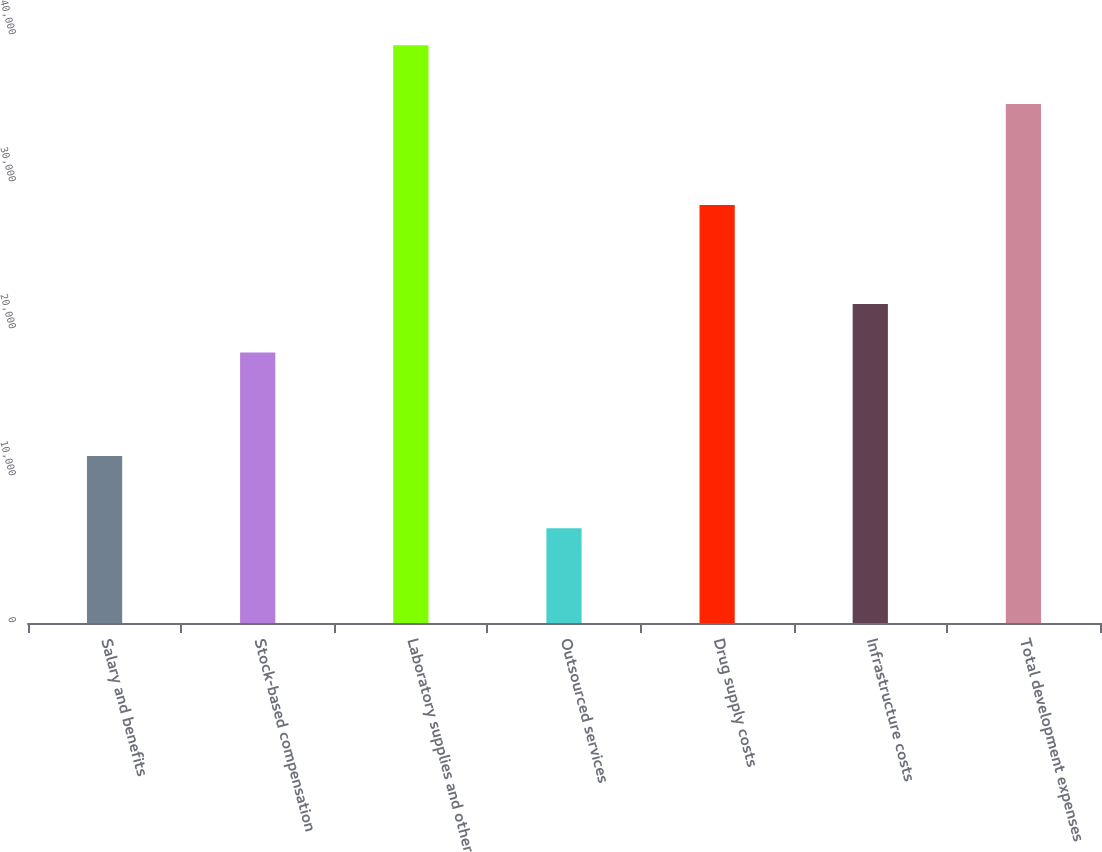Convert chart. <chart><loc_0><loc_0><loc_500><loc_500><bar_chart><fcel>Salary and benefits<fcel>Stock-based compensation<fcel>Laboratory supplies and other<fcel>Outsourced services<fcel>Drug supply costs<fcel>Infrastructure costs<fcel>Total development expenses<nl><fcel>11359<fcel>18409<fcel>39306<fcel>6438<fcel>28439<fcel>21695.8<fcel>35303<nl></chart> 